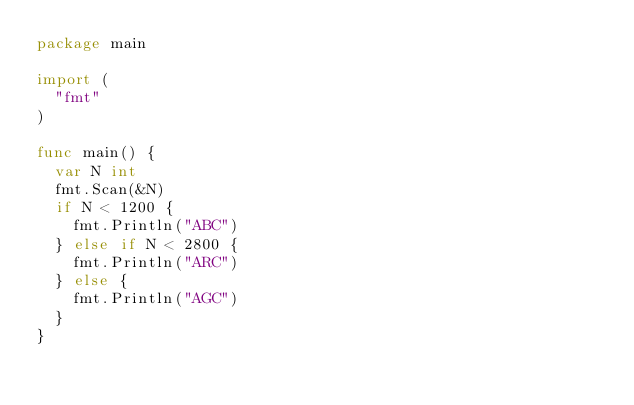Convert code to text. <code><loc_0><loc_0><loc_500><loc_500><_Go_>package main

import (
	"fmt"
)

func main() {
	var N int
	fmt.Scan(&N)
	if N < 1200 {
		fmt.Println("ABC")
	} else if N < 2800 {
		fmt.Println("ARC")
	} else {
		fmt.Println("AGC")
	}
}
</code> 